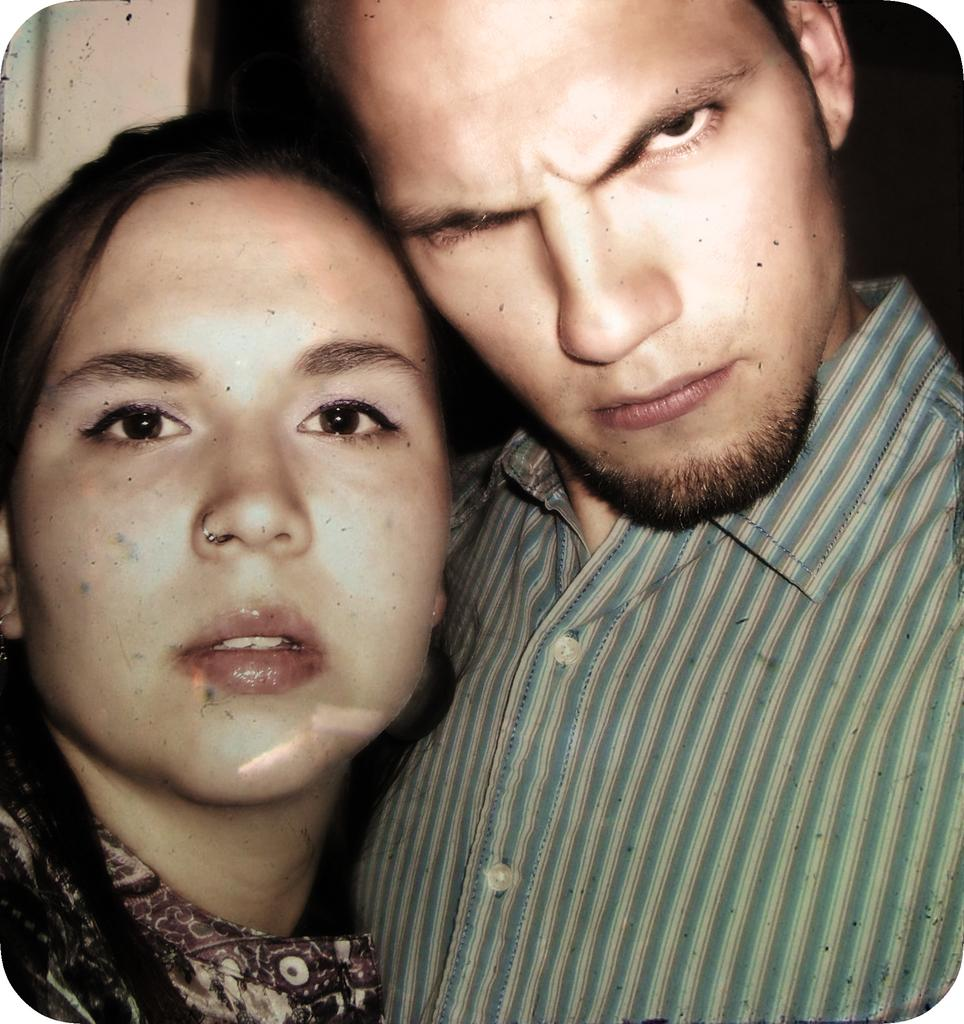How many people are present in the image? There are two people in the image, a man and a woman. What is the man wearing in the image? The man is wearing a shirt in the image. What type of train is visible in the background of the image? There is no train present in the image; it only features a man and a woman. What type of suit is the man wearing in the image? The man is not wearing a suit in the image; he is wearing a shirt. 